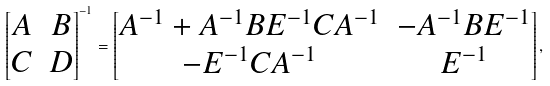<formula> <loc_0><loc_0><loc_500><loc_500>\begin{bmatrix} A & B \\ C & D \end{bmatrix} ^ { - 1 } = \begin{bmatrix} A ^ { - 1 } + A ^ { - 1 } B E ^ { - 1 } C A ^ { - 1 } & - A ^ { - 1 } B E ^ { - 1 } \\ - E ^ { - 1 } C A ^ { - 1 } & E ^ { - 1 } \end{bmatrix} ,</formula> 